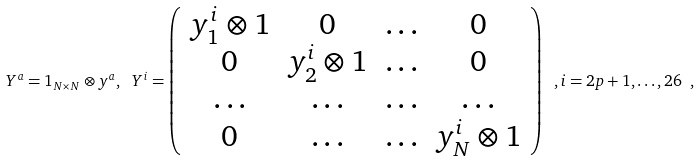Convert formula to latex. <formula><loc_0><loc_0><loc_500><loc_500>Y ^ { a } = 1 _ { N \times N } \otimes y ^ { a } , \ Y ^ { i } = \left ( \begin{array} { c c c c } { { y _ { 1 } ^ { i } \otimes 1 } } & { 0 } & { \dots } & { 0 } \\ { 0 } & { { y _ { 2 } ^ { i } \otimes 1 } } & { \dots } & { 0 } \\ { \dots } & { \dots } & { \dots } & { \dots } \\ { 0 } & { \dots } & { \dots } & { { y _ { N } ^ { i } \otimes 1 } } \end{array} \right ) \ , i = 2 p + 1 , \dots , 2 6 \ ,</formula> 